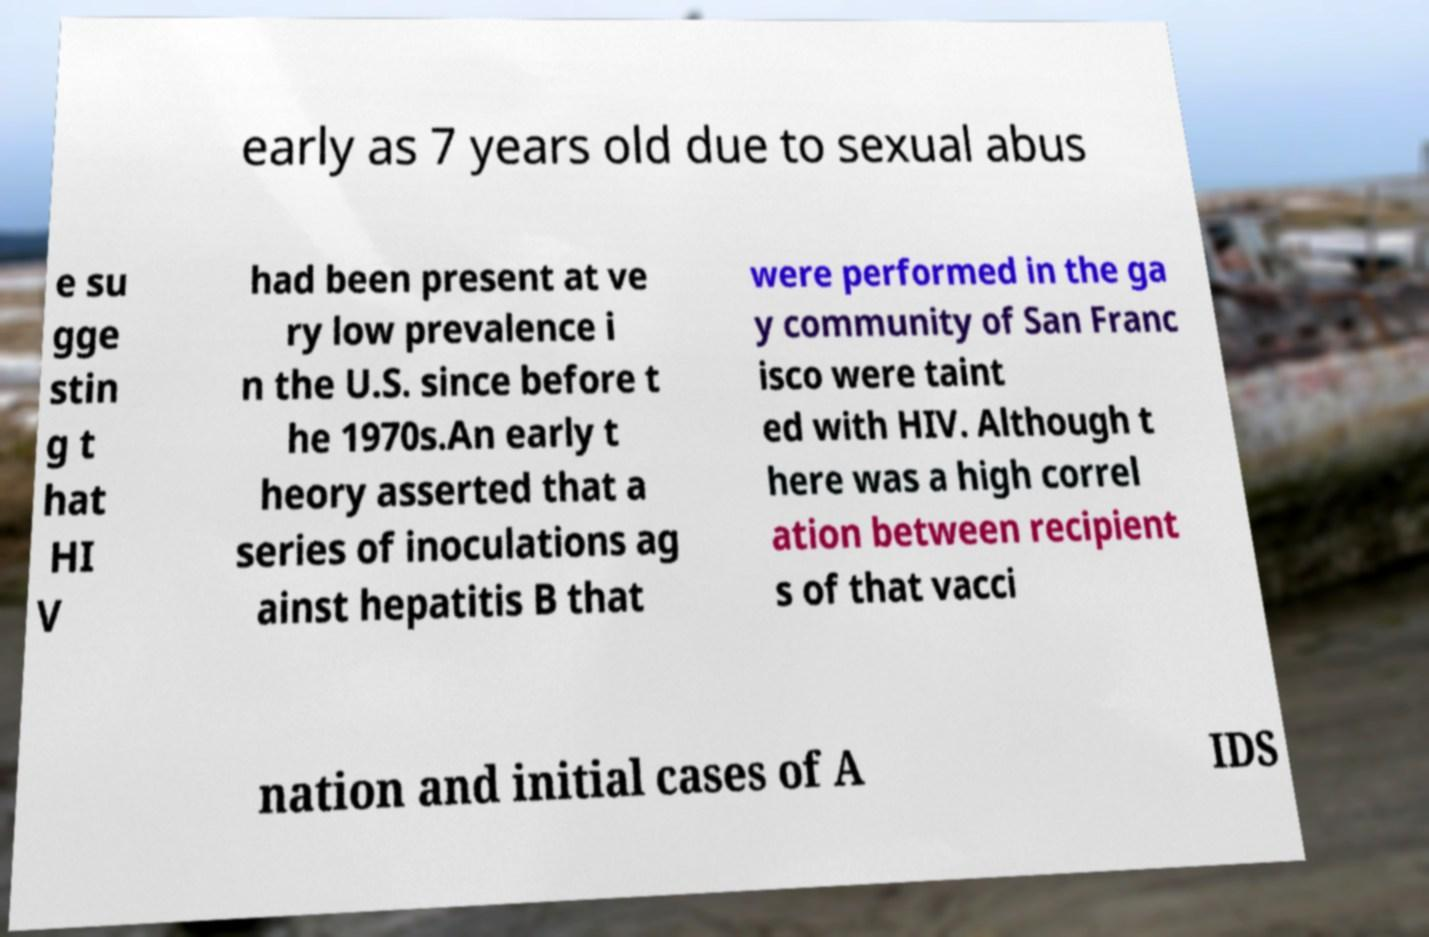What messages or text are displayed in this image? I need them in a readable, typed format. early as 7 years old due to sexual abus e su gge stin g t hat HI V had been present at ve ry low prevalence i n the U.S. since before t he 1970s.An early t heory asserted that a series of inoculations ag ainst hepatitis B that were performed in the ga y community of San Franc isco were taint ed with HIV. Although t here was a high correl ation between recipient s of that vacci nation and initial cases of A IDS 